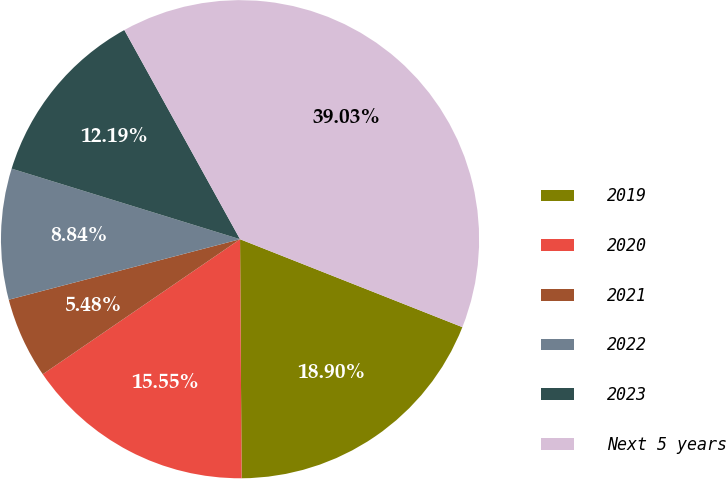Convert chart. <chart><loc_0><loc_0><loc_500><loc_500><pie_chart><fcel>2019<fcel>2020<fcel>2021<fcel>2022<fcel>2023<fcel>Next 5 years<nl><fcel>18.9%<fcel>15.55%<fcel>5.48%<fcel>8.84%<fcel>12.19%<fcel>39.03%<nl></chart> 